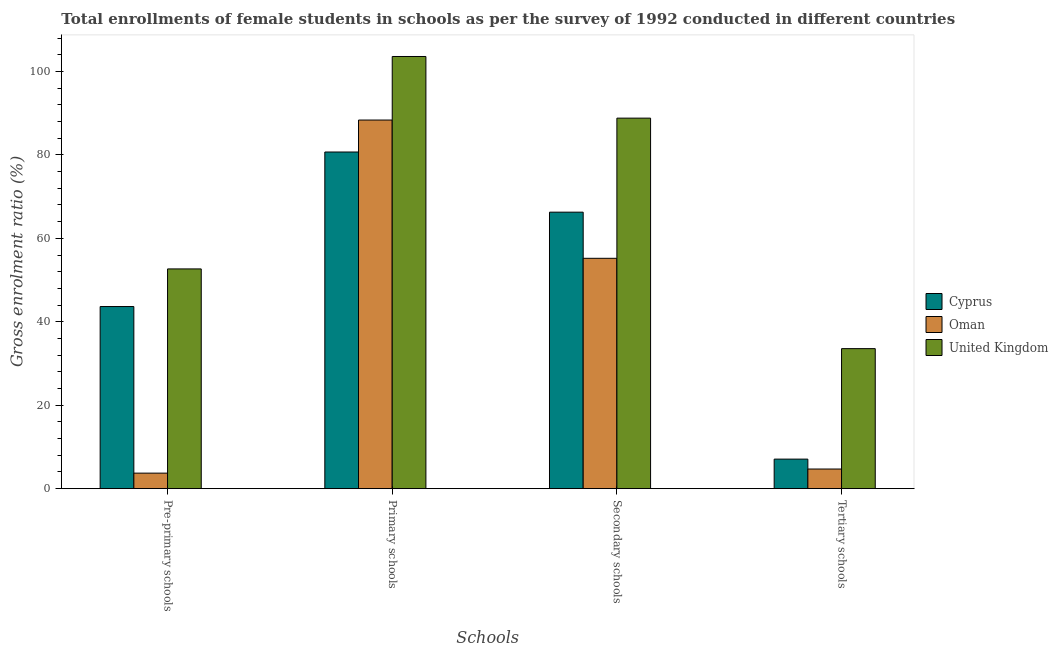How many different coloured bars are there?
Provide a short and direct response. 3. Are the number of bars per tick equal to the number of legend labels?
Make the answer very short. Yes. Are the number of bars on each tick of the X-axis equal?
Give a very brief answer. Yes. How many bars are there on the 3rd tick from the left?
Your answer should be very brief. 3. How many bars are there on the 2nd tick from the right?
Offer a very short reply. 3. What is the label of the 4th group of bars from the left?
Make the answer very short. Tertiary schools. What is the gross enrolment ratio(female) in secondary schools in Oman?
Keep it short and to the point. 55.21. Across all countries, what is the maximum gross enrolment ratio(female) in primary schools?
Make the answer very short. 103.57. Across all countries, what is the minimum gross enrolment ratio(female) in primary schools?
Your answer should be very brief. 80.68. In which country was the gross enrolment ratio(female) in primary schools minimum?
Make the answer very short. Cyprus. What is the total gross enrolment ratio(female) in primary schools in the graph?
Provide a short and direct response. 272.6. What is the difference between the gross enrolment ratio(female) in primary schools in Cyprus and that in United Kingdom?
Ensure brevity in your answer.  -22.89. What is the difference between the gross enrolment ratio(female) in primary schools in Cyprus and the gross enrolment ratio(female) in tertiary schools in Oman?
Make the answer very short. 75.97. What is the average gross enrolment ratio(female) in secondary schools per country?
Ensure brevity in your answer.  70.09. What is the difference between the gross enrolment ratio(female) in secondary schools and gross enrolment ratio(female) in tertiary schools in Oman?
Make the answer very short. 50.5. In how many countries, is the gross enrolment ratio(female) in pre-primary schools greater than 28 %?
Keep it short and to the point. 2. What is the ratio of the gross enrolment ratio(female) in pre-primary schools in Oman to that in Cyprus?
Your answer should be very brief. 0.09. What is the difference between the highest and the second highest gross enrolment ratio(female) in tertiary schools?
Your response must be concise. 26.48. What is the difference between the highest and the lowest gross enrolment ratio(female) in tertiary schools?
Your response must be concise. 28.85. Is the sum of the gross enrolment ratio(female) in secondary schools in United Kingdom and Cyprus greater than the maximum gross enrolment ratio(female) in tertiary schools across all countries?
Ensure brevity in your answer.  Yes. What does the 3rd bar from the left in Primary schools represents?
Your answer should be compact. United Kingdom. What does the 2nd bar from the right in Primary schools represents?
Your answer should be compact. Oman. Is it the case that in every country, the sum of the gross enrolment ratio(female) in pre-primary schools and gross enrolment ratio(female) in primary schools is greater than the gross enrolment ratio(female) in secondary schools?
Ensure brevity in your answer.  Yes. What is the difference between two consecutive major ticks on the Y-axis?
Your response must be concise. 20. How many legend labels are there?
Keep it short and to the point. 3. What is the title of the graph?
Your answer should be compact. Total enrollments of female students in schools as per the survey of 1992 conducted in different countries. What is the label or title of the X-axis?
Offer a terse response. Schools. What is the label or title of the Y-axis?
Offer a very short reply. Gross enrolment ratio (%). What is the Gross enrolment ratio (%) in Cyprus in Pre-primary schools?
Your answer should be very brief. 43.65. What is the Gross enrolment ratio (%) in Oman in Pre-primary schools?
Keep it short and to the point. 3.72. What is the Gross enrolment ratio (%) of United Kingdom in Pre-primary schools?
Your answer should be very brief. 52.66. What is the Gross enrolment ratio (%) in Cyprus in Primary schools?
Make the answer very short. 80.68. What is the Gross enrolment ratio (%) of Oman in Primary schools?
Make the answer very short. 88.34. What is the Gross enrolment ratio (%) in United Kingdom in Primary schools?
Offer a terse response. 103.57. What is the Gross enrolment ratio (%) in Cyprus in Secondary schools?
Your answer should be very brief. 66.26. What is the Gross enrolment ratio (%) in Oman in Secondary schools?
Give a very brief answer. 55.21. What is the Gross enrolment ratio (%) in United Kingdom in Secondary schools?
Give a very brief answer. 88.8. What is the Gross enrolment ratio (%) of Cyprus in Tertiary schools?
Give a very brief answer. 7.08. What is the Gross enrolment ratio (%) of Oman in Tertiary schools?
Provide a short and direct response. 4.71. What is the Gross enrolment ratio (%) in United Kingdom in Tertiary schools?
Offer a very short reply. 33.56. Across all Schools, what is the maximum Gross enrolment ratio (%) in Cyprus?
Offer a very short reply. 80.68. Across all Schools, what is the maximum Gross enrolment ratio (%) in Oman?
Your response must be concise. 88.34. Across all Schools, what is the maximum Gross enrolment ratio (%) of United Kingdom?
Your answer should be very brief. 103.57. Across all Schools, what is the minimum Gross enrolment ratio (%) of Cyprus?
Keep it short and to the point. 7.08. Across all Schools, what is the minimum Gross enrolment ratio (%) in Oman?
Give a very brief answer. 3.72. Across all Schools, what is the minimum Gross enrolment ratio (%) in United Kingdom?
Your answer should be very brief. 33.56. What is the total Gross enrolment ratio (%) in Cyprus in the graph?
Provide a short and direct response. 197.68. What is the total Gross enrolment ratio (%) in Oman in the graph?
Make the answer very short. 151.99. What is the total Gross enrolment ratio (%) in United Kingdom in the graph?
Your response must be concise. 278.6. What is the difference between the Gross enrolment ratio (%) in Cyprus in Pre-primary schools and that in Primary schools?
Keep it short and to the point. -37.03. What is the difference between the Gross enrolment ratio (%) in Oman in Pre-primary schools and that in Primary schools?
Your answer should be very brief. -84.62. What is the difference between the Gross enrolment ratio (%) of United Kingdom in Pre-primary schools and that in Primary schools?
Provide a succinct answer. -50.91. What is the difference between the Gross enrolment ratio (%) of Cyprus in Pre-primary schools and that in Secondary schools?
Keep it short and to the point. -22.62. What is the difference between the Gross enrolment ratio (%) of Oman in Pre-primary schools and that in Secondary schools?
Your response must be concise. -51.49. What is the difference between the Gross enrolment ratio (%) in United Kingdom in Pre-primary schools and that in Secondary schools?
Provide a succinct answer. -36.13. What is the difference between the Gross enrolment ratio (%) in Cyprus in Pre-primary schools and that in Tertiary schools?
Provide a succinct answer. 36.57. What is the difference between the Gross enrolment ratio (%) in Oman in Pre-primary schools and that in Tertiary schools?
Provide a short and direct response. -0.99. What is the difference between the Gross enrolment ratio (%) of United Kingdom in Pre-primary schools and that in Tertiary schools?
Ensure brevity in your answer.  19.1. What is the difference between the Gross enrolment ratio (%) of Cyprus in Primary schools and that in Secondary schools?
Give a very brief answer. 14.42. What is the difference between the Gross enrolment ratio (%) of Oman in Primary schools and that in Secondary schools?
Offer a very short reply. 33.13. What is the difference between the Gross enrolment ratio (%) in United Kingdom in Primary schools and that in Secondary schools?
Your answer should be very brief. 14.78. What is the difference between the Gross enrolment ratio (%) of Cyprus in Primary schools and that in Tertiary schools?
Provide a succinct answer. 73.6. What is the difference between the Gross enrolment ratio (%) in Oman in Primary schools and that in Tertiary schools?
Your answer should be compact. 83.64. What is the difference between the Gross enrolment ratio (%) of United Kingdom in Primary schools and that in Tertiary schools?
Provide a short and direct response. 70.01. What is the difference between the Gross enrolment ratio (%) of Cyprus in Secondary schools and that in Tertiary schools?
Keep it short and to the point. 59.18. What is the difference between the Gross enrolment ratio (%) of Oman in Secondary schools and that in Tertiary schools?
Provide a short and direct response. 50.5. What is the difference between the Gross enrolment ratio (%) of United Kingdom in Secondary schools and that in Tertiary schools?
Provide a short and direct response. 55.24. What is the difference between the Gross enrolment ratio (%) in Cyprus in Pre-primary schools and the Gross enrolment ratio (%) in Oman in Primary schools?
Make the answer very short. -44.7. What is the difference between the Gross enrolment ratio (%) of Cyprus in Pre-primary schools and the Gross enrolment ratio (%) of United Kingdom in Primary schools?
Ensure brevity in your answer.  -59.93. What is the difference between the Gross enrolment ratio (%) in Oman in Pre-primary schools and the Gross enrolment ratio (%) in United Kingdom in Primary schools?
Ensure brevity in your answer.  -99.85. What is the difference between the Gross enrolment ratio (%) of Cyprus in Pre-primary schools and the Gross enrolment ratio (%) of Oman in Secondary schools?
Provide a short and direct response. -11.56. What is the difference between the Gross enrolment ratio (%) in Cyprus in Pre-primary schools and the Gross enrolment ratio (%) in United Kingdom in Secondary schools?
Your answer should be compact. -45.15. What is the difference between the Gross enrolment ratio (%) of Oman in Pre-primary schools and the Gross enrolment ratio (%) of United Kingdom in Secondary schools?
Provide a short and direct response. -85.08. What is the difference between the Gross enrolment ratio (%) in Cyprus in Pre-primary schools and the Gross enrolment ratio (%) in Oman in Tertiary schools?
Give a very brief answer. 38.94. What is the difference between the Gross enrolment ratio (%) of Cyprus in Pre-primary schools and the Gross enrolment ratio (%) of United Kingdom in Tertiary schools?
Offer a very short reply. 10.09. What is the difference between the Gross enrolment ratio (%) of Oman in Pre-primary schools and the Gross enrolment ratio (%) of United Kingdom in Tertiary schools?
Provide a succinct answer. -29.84. What is the difference between the Gross enrolment ratio (%) in Cyprus in Primary schools and the Gross enrolment ratio (%) in Oman in Secondary schools?
Your answer should be compact. 25.47. What is the difference between the Gross enrolment ratio (%) in Cyprus in Primary schools and the Gross enrolment ratio (%) in United Kingdom in Secondary schools?
Your answer should be compact. -8.12. What is the difference between the Gross enrolment ratio (%) in Oman in Primary schools and the Gross enrolment ratio (%) in United Kingdom in Secondary schools?
Give a very brief answer. -0.46. What is the difference between the Gross enrolment ratio (%) in Cyprus in Primary schools and the Gross enrolment ratio (%) in Oman in Tertiary schools?
Your answer should be very brief. 75.97. What is the difference between the Gross enrolment ratio (%) of Cyprus in Primary schools and the Gross enrolment ratio (%) of United Kingdom in Tertiary schools?
Offer a terse response. 47.12. What is the difference between the Gross enrolment ratio (%) of Oman in Primary schools and the Gross enrolment ratio (%) of United Kingdom in Tertiary schools?
Your response must be concise. 54.78. What is the difference between the Gross enrolment ratio (%) of Cyprus in Secondary schools and the Gross enrolment ratio (%) of Oman in Tertiary schools?
Provide a short and direct response. 61.56. What is the difference between the Gross enrolment ratio (%) in Cyprus in Secondary schools and the Gross enrolment ratio (%) in United Kingdom in Tertiary schools?
Give a very brief answer. 32.7. What is the difference between the Gross enrolment ratio (%) of Oman in Secondary schools and the Gross enrolment ratio (%) of United Kingdom in Tertiary schools?
Give a very brief answer. 21.65. What is the average Gross enrolment ratio (%) in Cyprus per Schools?
Provide a succinct answer. 49.42. What is the average Gross enrolment ratio (%) of Oman per Schools?
Keep it short and to the point. 38. What is the average Gross enrolment ratio (%) in United Kingdom per Schools?
Keep it short and to the point. 69.65. What is the difference between the Gross enrolment ratio (%) of Cyprus and Gross enrolment ratio (%) of Oman in Pre-primary schools?
Ensure brevity in your answer.  39.92. What is the difference between the Gross enrolment ratio (%) in Cyprus and Gross enrolment ratio (%) in United Kingdom in Pre-primary schools?
Your response must be concise. -9.02. What is the difference between the Gross enrolment ratio (%) in Oman and Gross enrolment ratio (%) in United Kingdom in Pre-primary schools?
Provide a short and direct response. -48.94. What is the difference between the Gross enrolment ratio (%) in Cyprus and Gross enrolment ratio (%) in Oman in Primary schools?
Offer a terse response. -7.66. What is the difference between the Gross enrolment ratio (%) in Cyprus and Gross enrolment ratio (%) in United Kingdom in Primary schools?
Make the answer very short. -22.89. What is the difference between the Gross enrolment ratio (%) in Oman and Gross enrolment ratio (%) in United Kingdom in Primary schools?
Keep it short and to the point. -15.23. What is the difference between the Gross enrolment ratio (%) of Cyprus and Gross enrolment ratio (%) of Oman in Secondary schools?
Keep it short and to the point. 11.05. What is the difference between the Gross enrolment ratio (%) in Cyprus and Gross enrolment ratio (%) in United Kingdom in Secondary schools?
Provide a succinct answer. -22.53. What is the difference between the Gross enrolment ratio (%) of Oman and Gross enrolment ratio (%) of United Kingdom in Secondary schools?
Keep it short and to the point. -33.59. What is the difference between the Gross enrolment ratio (%) in Cyprus and Gross enrolment ratio (%) in Oman in Tertiary schools?
Provide a short and direct response. 2.37. What is the difference between the Gross enrolment ratio (%) of Cyprus and Gross enrolment ratio (%) of United Kingdom in Tertiary schools?
Your answer should be compact. -26.48. What is the difference between the Gross enrolment ratio (%) of Oman and Gross enrolment ratio (%) of United Kingdom in Tertiary schools?
Provide a succinct answer. -28.85. What is the ratio of the Gross enrolment ratio (%) of Cyprus in Pre-primary schools to that in Primary schools?
Make the answer very short. 0.54. What is the ratio of the Gross enrolment ratio (%) of Oman in Pre-primary schools to that in Primary schools?
Ensure brevity in your answer.  0.04. What is the ratio of the Gross enrolment ratio (%) of United Kingdom in Pre-primary schools to that in Primary schools?
Your answer should be very brief. 0.51. What is the ratio of the Gross enrolment ratio (%) of Cyprus in Pre-primary schools to that in Secondary schools?
Provide a succinct answer. 0.66. What is the ratio of the Gross enrolment ratio (%) of Oman in Pre-primary schools to that in Secondary schools?
Ensure brevity in your answer.  0.07. What is the ratio of the Gross enrolment ratio (%) of United Kingdom in Pre-primary schools to that in Secondary schools?
Offer a very short reply. 0.59. What is the ratio of the Gross enrolment ratio (%) in Cyprus in Pre-primary schools to that in Tertiary schools?
Your answer should be compact. 6.16. What is the ratio of the Gross enrolment ratio (%) of Oman in Pre-primary schools to that in Tertiary schools?
Ensure brevity in your answer.  0.79. What is the ratio of the Gross enrolment ratio (%) of United Kingdom in Pre-primary schools to that in Tertiary schools?
Your answer should be compact. 1.57. What is the ratio of the Gross enrolment ratio (%) of Cyprus in Primary schools to that in Secondary schools?
Keep it short and to the point. 1.22. What is the ratio of the Gross enrolment ratio (%) in Oman in Primary schools to that in Secondary schools?
Offer a terse response. 1.6. What is the ratio of the Gross enrolment ratio (%) of United Kingdom in Primary schools to that in Secondary schools?
Make the answer very short. 1.17. What is the ratio of the Gross enrolment ratio (%) in Cyprus in Primary schools to that in Tertiary schools?
Offer a very short reply. 11.39. What is the ratio of the Gross enrolment ratio (%) of Oman in Primary schools to that in Tertiary schools?
Your response must be concise. 18.76. What is the ratio of the Gross enrolment ratio (%) in United Kingdom in Primary schools to that in Tertiary schools?
Ensure brevity in your answer.  3.09. What is the ratio of the Gross enrolment ratio (%) of Cyprus in Secondary schools to that in Tertiary schools?
Give a very brief answer. 9.36. What is the ratio of the Gross enrolment ratio (%) of Oman in Secondary schools to that in Tertiary schools?
Your response must be concise. 11.72. What is the ratio of the Gross enrolment ratio (%) in United Kingdom in Secondary schools to that in Tertiary schools?
Offer a terse response. 2.65. What is the difference between the highest and the second highest Gross enrolment ratio (%) in Cyprus?
Your answer should be compact. 14.42. What is the difference between the highest and the second highest Gross enrolment ratio (%) in Oman?
Keep it short and to the point. 33.13. What is the difference between the highest and the second highest Gross enrolment ratio (%) in United Kingdom?
Offer a terse response. 14.78. What is the difference between the highest and the lowest Gross enrolment ratio (%) of Cyprus?
Provide a succinct answer. 73.6. What is the difference between the highest and the lowest Gross enrolment ratio (%) of Oman?
Offer a very short reply. 84.62. What is the difference between the highest and the lowest Gross enrolment ratio (%) in United Kingdom?
Give a very brief answer. 70.01. 